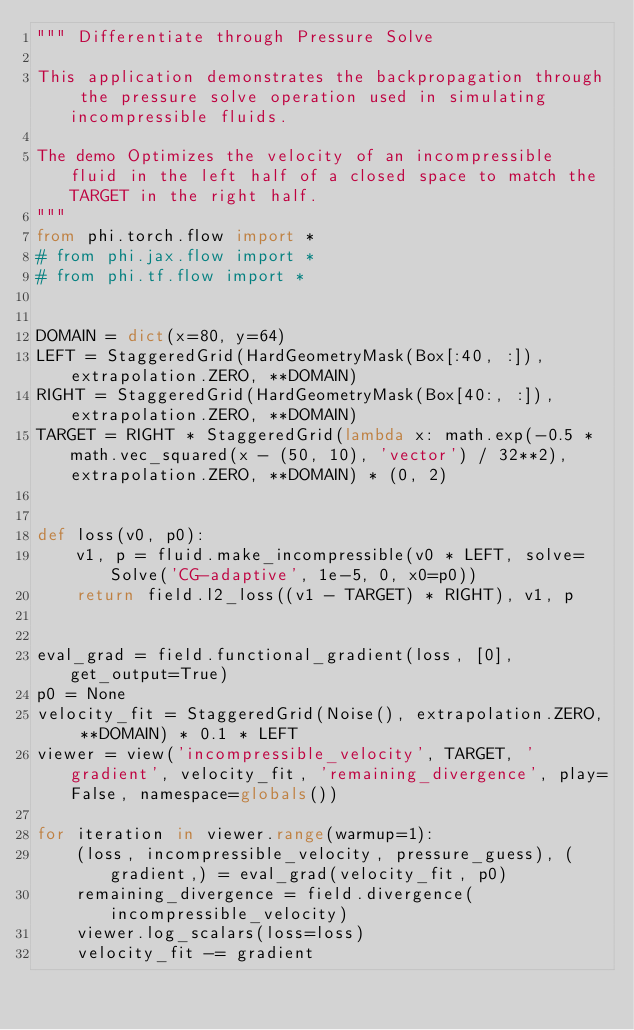<code> <loc_0><loc_0><loc_500><loc_500><_Python_>""" Differentiate through Pressure Solve

This application demonstrates the backpropagation through the pressure solve operation used in simulating incompressible fluids.

The demo Optimizes the velocity of an incompressible fluid in the left half of a closed space to match the TARGET in the right half.
"""
from phi.torch.flow import *
# from phi.jax.flow import *
# from phi.tf.flow import *


DOMAIN = dict(x=80, y=64)
LEFT = StaggeredGrid(HardGeometryMask(Box[:40, :]), extrapolation.ZERO, **DOMAIN)
RIGHT = StaggeredGrid(HardGeometryMask(Box[40:, :]), extrapolation.ZERO, **DOMAIN)
TARGET = RIGHT * StaggeredGrid(lambda x: math.exp(-0.5 * math.vec_squared(x - (50, 10), 'vector') / 32**2), extrapolation.ZERO, **DOMAIN) * (0, 2)


def loss(v0, p0):
    v1, p = fluid.make_incompressible(v0 * LEFT, solve=Solve('CG-adaptive', 1e-5, 0, x0=p0))
    return field.l2_loss((v1 - TARGET) * RIGHT), v1, p


eval_grad = field.functional_gradient(loss, [0], get_output=True)
p0 = None
velocity_fit = StaggeredGrid(Noise(), extrapolation.ZERO, **DOMAIN) * 0.1 * LEFT
viewer = view('incompressible_velocity', TARGET, 'gradient', velocity_fit, 'remaining_divergence', play=False, namespace=globals())

for iteration in viewer.range(warmup=1):
    (loss, incompressible_velocity, pressure_guess), (gradient,) = eval_grad(velocity_fit, p0)
    remaining_divergence = field.divergence(incompressible_velocity)
    viewer.log_scalars(loss=loss)
    velocity_fit -= gradient
</code> 